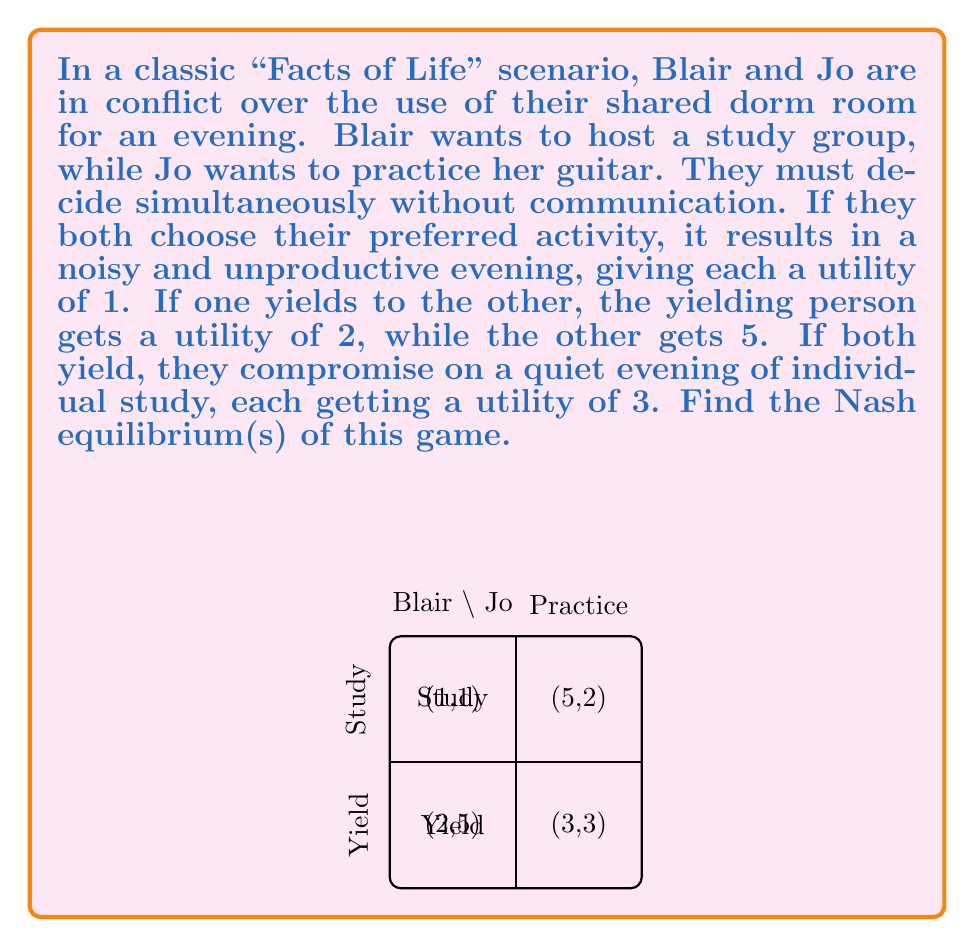Can you solve this math problem? To find the Nash equilibrium, we need to analyze each player's best response to the other's strategy:

1) First, let's write out the payoff matrix:
   $$
   \begin{array}{c|c|c}
   \text{Blair } \backslash \text{ Jo} & \text{Practice} & \text{Yield} \\
   \hline
   \text{Study} & (1,1) & (5,2) \\
   \hline
   \text{Yield} & (2,5) & (3,3)
   \end{array}
   $$

2) For Blair:
   - If Jo practices, Blair's best response is to yield (2 > 1)
   - If Jo yields, Blair's best response is to study (5 > 3)

3) For Jo:
   - If Blair studies, Jo's best response is to yield (2 > 1)
   - If Blair yields, Jo's best response is to practice (5 > 3)

4) A Nash equilibrium occurs when each player is playing their best response to the other's strategy. From our analysis, we can see that there are two such situations:
   - (Study, Yield): Blair studies and Jo yields
   - (Yield, Practice): Blair yields and Jo practices

5) To verify, let's check that no player wants to unilaterally deviate:
   - In (Study, Yield), Blair gets 5 and Jo gets 2. If Blair switches to Yield, she'd get 3. If Jo switches to Practice, she'd get 1.
   - In (Yield, Practice), Blair gets 2 and Jo gets 5. If Blair switches to Study, she'd get 1. If Jo switches to Yield, she'd get 3.

Therefore, both (Study, Yield) and (Yield, Practice) are Nash equilibria.
Answer: Two Nash equilibria: (Study, Yield) and (Yield, Practice) 